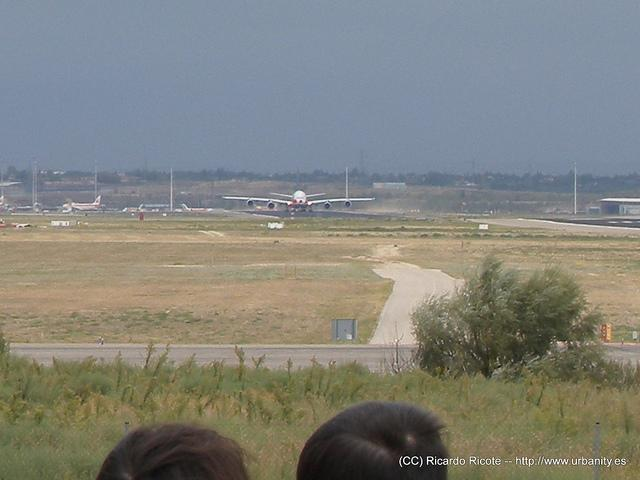Who gives the airplanes guidelines on where to take off and land? airtraffic controllers 